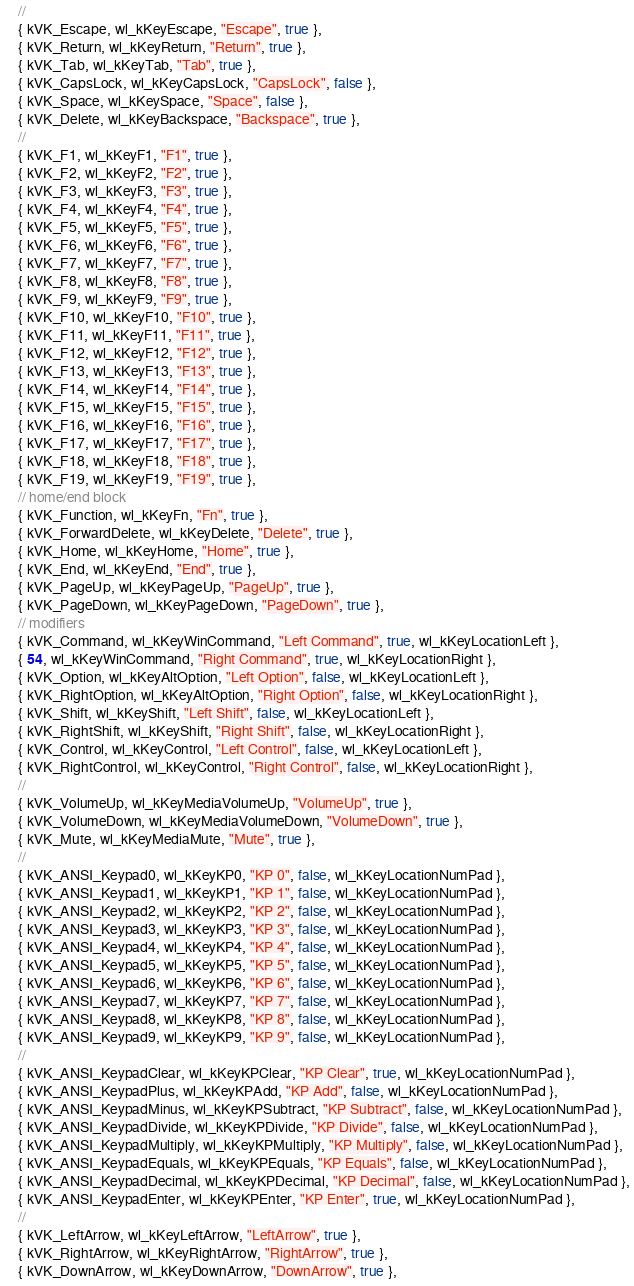<code> <loc_0><loc_0><loc_500><loc_500><_ObjectiveC_>    //
    { kVK_Escape, wl_kKeyEscape, "Escape", true },
    { kVK_Return, wl_kKeyReturn, "Return", true },
    { kVK_Tab, wl_kKeyTab, "Tab", true },
    { kVK_CapsLock, wl_kKeyCapsLock, "CapsLock", false },
    { kVK_Space, wl_kKeySpace, "Space", false },
    { kVK_Delete, wl_kKeyBackspace, "Backspace", true },
    //
    { kVK_F1, wl_kKeyF1, "F1", true },
    { kVK_F2, wl_kKeyF2, "F2", true },
    { kVK_F3, wl_kKeyF3, "F3", true },
    { kVK_F4, wl_kKeyF4, "F4", true },
    { kVK_F5, wl_kKeyF5, "F5", true },
    { kVK_F6, wl_kKeyF6, "F6", true },
    { kVK_F7, wl_kKeyF7, "F7", true },
    { kVK_F8, wl_kKeyF8, "F8", true },
    { kVK_F9, wl_kKeyF9, "F9", true },
    { kVK_F10, wl_kKeyF10, "F10", true },
    { kVK_F11, wl_kKeyF11, "F11", true },
    { kVK_F12, wl_kKeyF12, "F12", true },
    { kVK_F13, wl_kKeyF13, "F13", true },
    { kVK_F14, wl_kKeyF14, "F14", true },
    { kVK_F15, wl_kKeyF15, "F15", true },
    { kVK_F16, wl_kKeyF16, "F16", true },
    { kVK_F17, wl_kKeyF17, "F17", true },
    { kVK_F18, wl_kKeyF18, "F18", true },
    { kVK_F19, wl_kKeyF19, "F19", true },
    // home/end block
    { kVK_Function, wl_kKeyFn, "Fn", true },
    { kVK_ForwardDelete, wl_kKeyDelete, "Delete", true },
    { kVK_Home, wl_kKeyHome, "Home", true },
    { kVK_End, wl_kKeyEnd, "End", true },
    { kVK_PageUp, wl_kKeyPageUp, "PageUp", true },
    { kVK_PageDown, wl_kKeyPageDown, "PageDown", true },
    // modifiers
    { kVK_Command, wl_kKeyWinCommand, "Left Command", true, wl_kKeyLocationLeft },
    { 54, wl_kKeyWinCommand, "Right Command", true, wl_kKeyLocationRight },
    { kVK_Option, wl_kKeyAltOption, "Left Option", false, wl_kKeyLocationLeft },
    { kVK_RightOption, wl_kKeyAltOption, "Right Option", false, wl_kKeyLocationRight },
    { kVK_Shift, wl_kKeyShift, "Left Shift", false, wl_kKeyLocationLeft },
    { kVK_RightShift, wl_kKeyShift, "Right Shift", false, wl_kKeyLocationRight },
    { kVK_Control, wl_kKeyControl, "Left Control", false, wl_kKeyLocationLeft },
    { kVK_RightControl, wl_kKeyControl, "Right Control", false, wl_kKeyLocationRight },
    //
    { kVK_VolumeUp, wl_kKeyMediaVolumeUp, "VolumeUp", true },
    { kVK_VolumeDown, wl_kKeyMediaVolumeDown, "VolumeDown", true },
    { kVK_Mute, wl_kKeyMediaMute, "Mute", true },
    //
    { kVK_ANSI_Keypad0, wl_kKeyKP0, "KP 0", false, wl_kKeyLocationNumPad },
    { kVK_ANSI_Keypad1, wl_kKeyKP1, "KP 1", false, wl_kKeyLocationNumPad },
    { kVK_ANSI_Keypad2, wl_kKeyKP2, "KP 2", false, wl_kKeyLocationNumPad },
    { kVK_ANSI_Keypad3, wl_kKeyKP3, "KP 3", false, wl_kKeyLocationNumPad },
    { kVK_ANSI_Keypad4, wl_kKeyKP4, "KP 4", false, wl_kKeyLocationNumPad },
    { kVK_ANSI_Keypad5, wl_kKeyKP5, "KP 5", false, wl_kKeyLocationNumPad },
    { kVK_ANSI_Keypad6, wl_kKeyKP6, "KP 6", false, wl_kKeyLocationNumPad },
    { kVK_ANSI_Keypad7, wl_kKeyKP7, "KP 7", false, wl_kKeyLocationNumPad },
    { kVK_ANSI_Keypad8, wl_kKeyKP8, "KP 8", false, wl_kKeyLocationNumPad },
    { kVK_ANSI_Keypad9, wl_kKeyKP9, "KP 9", false, wl_kKeyLocationNumPad },
    //
    { kVK_ANSI_KeypadClear, wl_kKeyKPClear, "KP Clear", true, wl_kKeyLocationNumPad },
    { kVK_ANSI_KeypadPlus, wl_kKeyKPAdd, "KP Add", false, wl_kKeyLocationNumPad },
    { kVK_ANSI_KeypadMinus, wl_kKeyKPSubtract, "KP Subtract", false, wl_kKeyLocationNumPad },
    { kVK_ANSI_KeypadDivide, wl_kKeyKPDivide, "KP Divide", false, wl_kKeyLocationNumPad },
    { kVK_ANSI_KeypadMultiply, wl_kKeyKPMultiply, "KP Multiply", false, wl_kKeyLocationNumPad },
    { kVK_ANSI_KeypadEquals, wl_kKeyKPEquals, "KP Equals", false, wl_kKeyLocationNumPad },
    { kVK_ANSI_KeypadDecimal, wl_kKeyKPDecimal, "KP Decimal", false, wl_kKeyLocationNumPad },
    { kVK_ANSI_KeypadEnter, wl_kKeyKPEnter, "KP Enter", true, wl_kKeyLocationNumPad },
    //
    { kVK_LeftArrow, wl_kKeyLeftArrow, "LeftArrow", true },
    { kVK_RightArrow, wl_kKeyRightArrow, "RightArrow", true },
    { kVK_DownArrow, wl_kKeyDownArrow, "DownArrow", true },</code> 